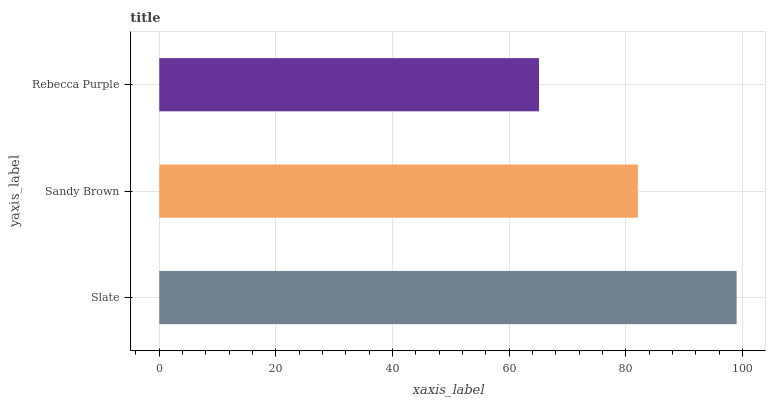Is Rebecca Purple the minimum?
Answer yes or no. Yes. Is Slate the maximum?
Answer yes or no. Yes. Is Sandy Brown the minimum?
Answer yes or no. No. Is Sandy Brown the maximum?
Answer yes or no. No. Is Slate greater than Sandy Brown?
Answer yes or no. Yes. Is Sandy Brown less than Slate?
Answer yes or no. Yes. Is Sandy Brown greater than Slate?
Answer yes or no. No. Is Slate less than Sandy Brown?
Answer yes or no. No. Is Sandy Brown the high median?
Answer yes or no. Yes. Is Sandy Brown the low median?
Answer yes or no. Yes. Is Rebecca Purple the high median?
Answer yes or no. No. Is Slate the low median?
Answer yes or no. No. 